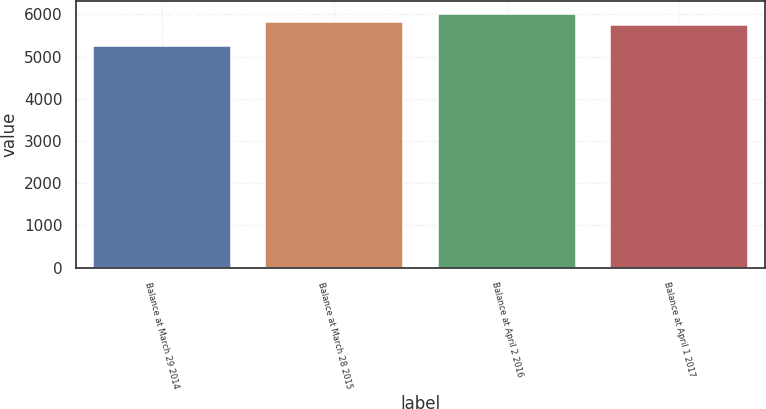<chart> <loc_0><loc_0><loc_500><loc_500><bar_chart><fcel>Balance at March 29 2014<fcel>Balance at March 28 2015<fcel>Balance at April 2 2016<fcel>Balance at April 1 2017<nl><fcel>5257.1<fcel>5827.69<fcel>6015<fcel>5751.9<nl></chart> 